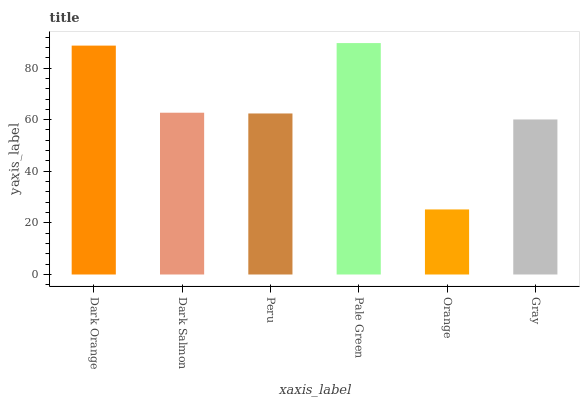Is Orange the minimum?
Answer yes or no. Yes. Is Pale Green the maximum?
Answer yes or no. Yes. Is Dark Salmon the minimum?
Answer yes or no. No. Is Dark Salmon the maximum?
Answer yes or no. No. Is Dark Orange greater than Dark Salmon?
Answer yes or no. Yes. Is Dark Salmon less than Dark Orange?
Answer yes or no. Yes. Is Dark Salmon greater than Dark Orange?
Answer yes or no. No. Is Dark Orange less than Dark Salmon?
Answer yes or no. No. Is Dark Salmon the high median?
Answer yes or no. Yes. Is Peru the low median?
Answer yes or no. Yes. Is Gray the high median?
Answer yes or no. No. Is Gray the low median?
Answer yes or no. No. 